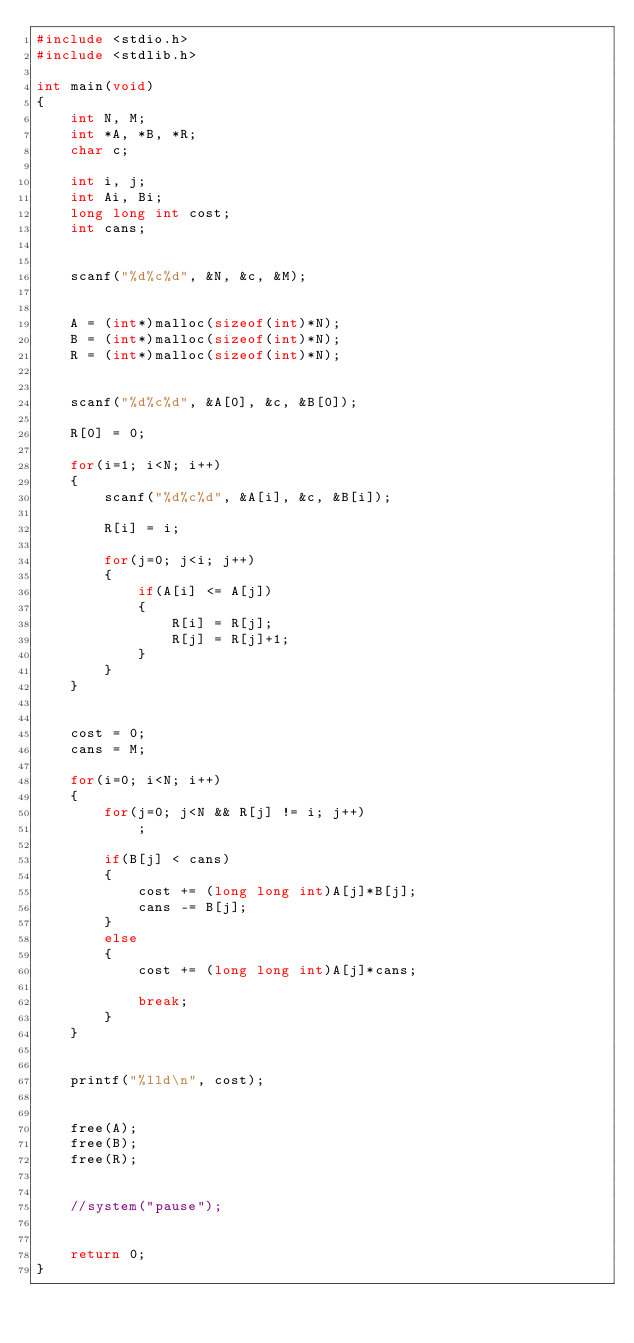<code> <loc_0><loc_0><loc_500><loc_500><_C_>#include <stdio.h>
#include <stdlib.h>

int main(void)
{
    int N, M;
    int *A, *B, *R;
    char c;
    
    int i, j;
    int Ai, Bi;
    long long int cost;
    int cans;
    
    
    scanf("%d%c%d", &N, &c, &M);
    
    
    A = (int*)malloc(sizeof(int)*N);
    B = (int*)malloc(sizeof(int)*N);
    R = (int*)malloc(sizeof(int)*N);
    
    
    scanf("%d%c%d", &A[0], &c, &B[0]);
    
    R[0] = 0;
    
    for(i=1; i<N; i++)
    {
        scanf("%d%c%d", &A[i], &c, &B[i]);
        
        R[i] = i;
        
        for(j=0; j<i; j++)
        {
            if(A[i] <= A[j])
            {
                R[i] = R[j];
                R[j] = R[j]+1;
            }
        }
    }

    
    cost = 0;
    cans = M;
    
    for(i=0; i<N; i++)
    {
        for(j=0; j<N && R[j] != i; j++)
            ;
        
        if(B[j] < cans)
        {
            cost += (long long int)A[j]*B[j];
            cans -= B[j];
        }
        else
        {
            cost += (long long int)A[j]*cans;
                    
            break;
        }
    }
    
    
    printf("%lld\n", cost);
    
    
    free(A);
    free(B);
    free(R);
    
    
    //system("pause");
    
    
    return 0;
}
</code> 